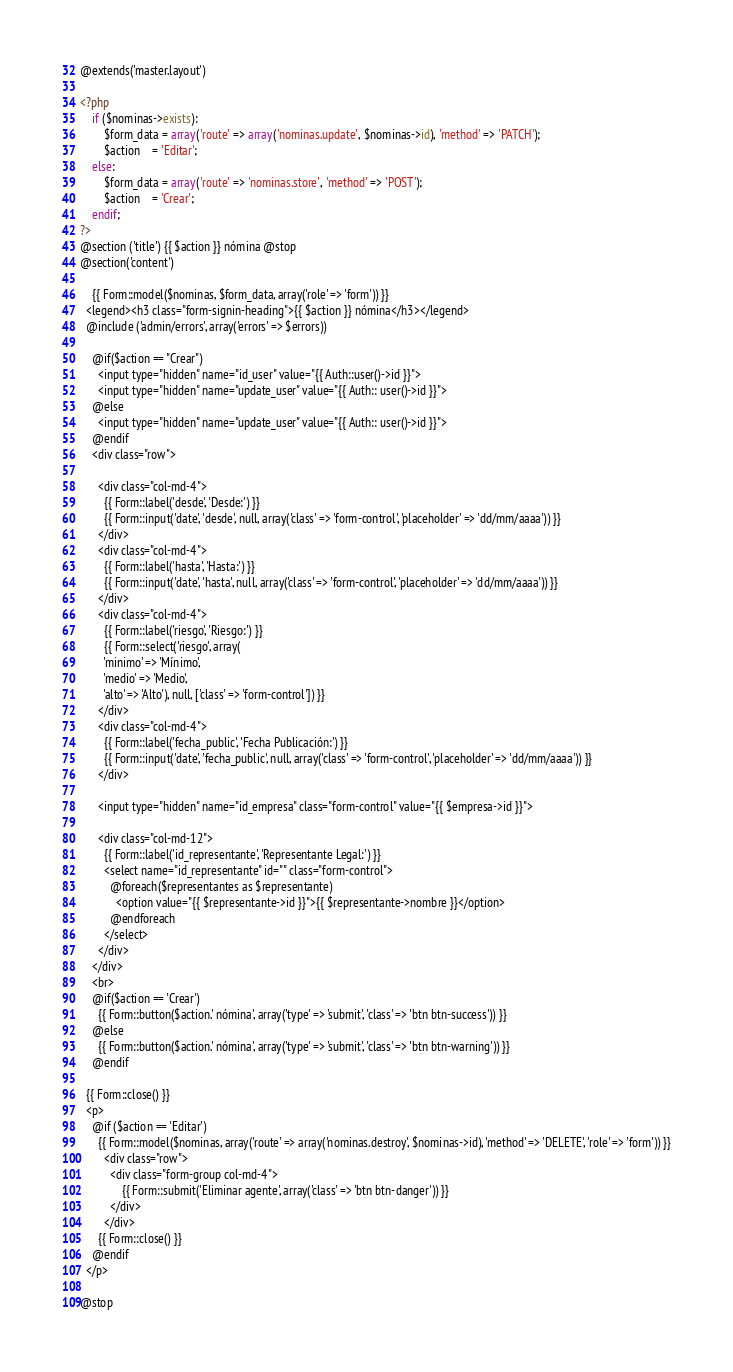<code> <loc_0><loc_0><loc_500><loc_500><_PHP_>@extends('master.layout')

<?php
    if ($nominas->exists):
        $form_data = array('route' => array('nominas.update', $nominas->id), 'method' => 'PATCH');
        $action    = 'Editar';
    else:
        $form_data = array('route' => 'nominas.store', 'method' => 'POST');
        $action    = 'Crear';        
    endif;
?>
@section ('title') {{ $action }} nómina @stop
@section('content')
  
	{{ Form::model($nominas, $form_data, array('role' => 'form')) }}
  <legend><h3 class="form-signin-heading">{{ $action }} nómina</h3></legend>
  @include ('admin/errors', array('errors' => $errors))
    
    @if($action == "Crear")
      <input type="hidden" name="id_user" value="{{ Auth::user()->id }}">
      <input type="hidden" name="update_user" value="{{ Auth:: user()->id }}">
    @else 
      <input type="hidden" name="update_user" value="{{ Auth:: user()->id }}">
    @endif
    <div class="row">
     
      <div class="col-md-4">
        {{ Form::label('desde', 'Desde:') }}
        {{ Form::input('date', 'desde', null, array('class' => 'form-control', 'placeholder' => 'dd/mm/aaaa')) }}
      </div>
      <div class="col-md-4">
        {{ Form::label('hasta', 'Hasta:') }}
        {{ Form::input('date', 'hasta', null, array('class' => 'form-control', 'placeholder' => 'dd/mm/aaaa')) }}
      </div>
      <div class="col-md-4">
        {{ Form::label('riesgo', 'Riesgo:') }}
        {{ Form::select('riesgo', array(
        'minimo' => 'Mínimo',
        'medio' => 'Medio',
        'alto' => 'Alto'), null, ['class' => 'form-control']) }}
      </div>
      <div class="col-md-4">
        {{ Form::label('fecha_public', 'Fecha Publicación:') }}
        {{ Form::input('date', 'fecha_public', null, array('class' => 'form-control', 'placeholder' => 'dd/mm/aaaa')) }}
      </div>
      
      <input type="hidden" name="id_empresa" class="form-control" value="{{ $empresa->id }}">
     
      <div class="col-md-12">
        {{ Form::label('id_representante', 'Representante Legal:') }}
        <select name="id_representante" id="" class="form-control">
          @foreach($representantes as $representante)
            <option value="{{ $representante->id }}">{{ $representante->nombre }}</option>
          @endforeach
        </select>
      </div>
    </div>   
    <br>     
    @if($action == 'Crear')
      {{ Form::button($action.' nómina', array('type' => 'submit', 'class' => 'btn btn-success')) }}
    @else 
      {{ Form::button($action.' nómina', array('type' => 'submit', 'class' => 'btn btn-warning')) }}
    @endif
   
  {{ Form::close() }}
  <p>
    @if ($action == 'Editar')  
      {{ Form::model($nominas, array('route' => array('nominas.destroy', $nominas->id), 'method' => 'DELETE', 'role' => 'form')) }}
        <div class="row">
          <div class="form-group col-md-4">
              {{ Form::submit('Eliminar agente', array('class' => 'btn btn-danger')) }}
          </div>
        </div>
      {{ Form::close() }}
    @endif
  </p>

@stop</code> 